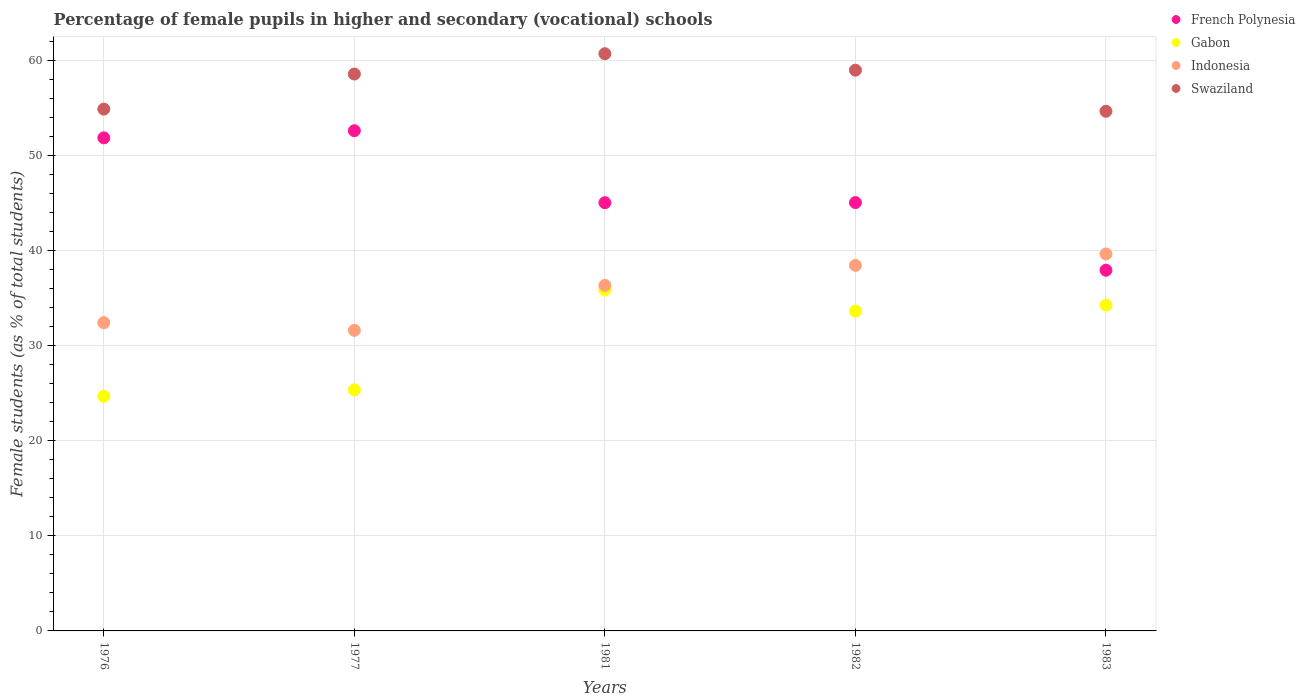What is the percentage of female pupils in higher and secondary schools in Gabon in 1982?
Give a very brief answer. 33.63. Across all years, what is the maximum percentage of female pupils in higher and secondary schools in Indonesia?
Provide a succinct answer. 39.64. Across all years, what is the minimum percentage of female pupils in higher and secondary schools in Gabon?
Provide a succinct answer. 24.67. In which year was the percentage of female pupils in higher and secondary schools in Gabon maximum?
Give a very brief answer. 1981. In which year was the percentage of female pupils in higher and secondary schools in Swaziland minimum?
Your answer should be compact. 1983. What is the total percentage of female pupils in higher and secondary schools in French Polynesia in the graph?
Give a very brief answer. 232.46. What is the difference between the percentage of female pupils in higher and secondary schools in Gabon in 1981 and that in 1983?
Your answer should be compact. 1.6. What is the difference between the percentage of female pupils in higher and secondary schools in French Polynesia in 1976 and the percentage of female pupils in higher and secondary schools in Swaziland in 1982?
Your response must be concise. -7.12. What is the average percentage of female pupils in higher and secondary schools in French Polynesia per year?
Your answer should be compact. 46.49. In the year 1981, what is the difference between the percentage of female pupils in higher and secondary schools in Gabon and percentage of female pupils in higher and secondary schools in Swaziland?
Your response must be concise. -24.84. In how many years, is the percentage of female pupils in higher and secondary schools in Gabon greater than 12 %?
Give a very brief answer. 5. What is the ratio of the percentage of female pupils in higher and secondary schools in French Polynesia in 1976 to that in 1977?
Provide a succinct answer. 0.99. What is the difference between the highest and the second highest percentage of female pupils in higher and secondary schools in French Polynesia?
Offer a terse response. 0.75. What is the difference between the highest and the lowest percentage of female pupils in higher and secondary schools in French Polynesia?
Provide a succinct answer. 14.67. Is the sum of the percentage of female pupils in higher and secondary schools in Swaziland in 1982 and 1983 greater than the maximum percentage of female pupils in higher and secondary schools in Gabon across all years?
Provide a succinct answer. Yes. Is it the case that in every year, the sum of the percentage of female pupils in higher and secondary schools in Swaziland and percentage of female pupils in higher and secondary schools in Indonesia  is greater than the percentage of female pupils in higher and secondary schools in French Polynesia?
Offer a very short reply. Yes. Is the percentage of female pupils in higher and secondary schools in French Polynesia strictly less than the percentage of female pupils in higher and secondary schools in Indonesia over the years?
Offer a terse response. No. How many years are there in the graph?
Your answer should be compact. 5. What is the difference between two consecutive major ticks on the Y-axis?
Give a very brief answer. 10. Are the values on the major ticks of Y-axis written in scientific E-notation?
Make the answer very short. No. Does the graph contain any zero values?
Ensure brevity in your answer.  No. How many legend labels are there?
Keep it short and to the point. 4. What is the title of the graph?
Your answer should be compact. Percentage of female pupils in higher and secondary (vocational) schools. Does "Kuwait" appear as one of the legend labels in the graph?
Provide a short and direct response. No. What is the label or title of the Y-axis?
Your answer should be compact. Female students (as % of total students). What is the Female students (as % of total students) in French Polynesia in 1976?
Provide a succinct answer. 51.85. What is the Female students (as % of total students) in Gabon in 1976?
Provide a succinct answer. 24.67. What is the Female students (as % of total students) in Indonesia in 1976?
Keep it short and to the point. 32.42. What is the Female students (as % of total students) of Swaziland in 1976?
Provide a short and direct response. 54.87. What is the Female students (as % of total students) of French Polynesia in 1977?
Ensure brevity in your answer.  52.6. What is the Female students (as % of total students) of Gabon in 1977?
Give a very brief answer. 25.35. What is the Female students (as % of total students) of Indonesia in 1977?
Your response must be concise. 31.61. What is the Female students (as % of total students) in Swaziland in 1977?
Ensure brevity in your answer.  58.56. What is the Female students (as % of total students) in French Polynesia in 1981?
Keep it short and to the point. 45.03. What is the Female students (as % of total students) of Gabon in 1981?
Make the answer very short. 35.86. What is the Female students (as % of total students) in Indonesia in 1981?
Your response must be concise. 36.34. What is the Female students (as % of total students) of Swaziland in 1981?
Your response must be concise. 60.7. What is the Female students (as % of total students) of French Polynesia in 1982?
Offer a very short reply. 45.04. What is the Female students (as % of total students) in Gabon in 1982?
Make the answer very short. 33.63. What is the Female students (as % of total students) of Indonesia in 1982?
Ensure brevity in your answer.  38.44. What is the Female students (as % of total students) in Swaziland in 1982?
Your response must be concise. 58.97. What is the Female students (as % of total students) in French Polynesia in 1983?
Provide a succinct answer. 37.93. What is the Female students (as % of total students) of Gabon in 1983?
Provide a short and direct response. 34.26. What is the Female students (as % of total students) in Indonesia in 1983?
Provide a succinct answer. 39.64. What is the Female students (as % of total students) of Swaziland in 1983?
Ensure brevity in your answer.  54.65. Across all years, what is the maximum Female students (as % of total students) in French Polynesia?
Your response must be concise. 52.6. Across all years, what is the maximum Female students (as % of total students) of Gabon?
Your answer should be compact. 35.86. Across all years, what is the maximum Female students (as % of total students) in Indonesia?
Provide a succinct answer. 39.64. Across all years, what is the maximum Female students (as % of total students) of Swaziland?
Your answer should be very brief. 60.7. Across all years, what is the minimum Female students (as % of total students) in French Polynesia?
Offer a very short reply. 37.93. Across all years, what is the minimum Female students (as % of total students) of Gabon?
Your answer should be very brief. 24.67. Across all years, what is the minimum Female students (as % of total students) of Indonesia?
Offer a very short reply. 31.61. Across all years, what is the minimum Female students (as % of total students) in Swaziland?
Provide a succinct answer. 54.65. What is the total Female students (as % of total students) of French Polynesia in the graph?
Make the answer very short. 232.46. What is the total Female students (as % of total students) in Gabon in the graph?
Offer a terse response. 153.77. What is the total Female students (as % of total students) in Indonesia in the graph?
Provide a short and direct response. 178.44. What is the total Female students (as % of total students) of Swaziland in the graph?
Your response must be concise. 287.75. What is the difference between the Female students (as % of total students) in French Polynesia in 1976 and that in 1977?
Give a very brief answer. -0.75. What is the difference between the Female students (as % of total students) of Gabon in 1976 and that in 1977?
Your answer should be very brief. -0.68. What is the difference between the Female students (as % of total students) in Indonesia in 1976 and that in 1977?
Your response must be concise. 0.81. What is the difference between the Female students (as % of total students) in Swaziland in 1976 and that in 1977?
Offer a terse response. -3.69. What is the difference between the Female students (as % of total students) of French Polynesia in 1976 and that in 1981?
Offer a terse response. 6.82. What is the difference between the Female students (as % of total students) in Gabon in 1976 and that in 1981?
Offer a very short reply. -11.19. What is the difference between the Female students (as % of total students) of Indonesia in 1976 and that in 1981?
Make the answer very short. -3.92. What is the difference between the Female students (as % of total students) in Swaziland in 1976 and that in 1981?
Your answer should be compact. -5.83. What is the difference between the Female students (as % of total students) of French Polynesia in 1976 and that in 1982?
Offer a terse response. 6.81. What is the difference between the Female students (as % of total students) of Gabon in 1976 and that in 1982?
Your answer should be compact. -8.96. What is the difference between the Female students (as % of total students) in Indonesia in 1976 and that in 1982?
Offer a very short reply. -6.02. What is the difference between the Female students (as % of total students) in Swaziland in 1976 and that in 1982?
Your answer should be very brief. -4.09. What is the difference between the Female students (as % of total students) of French Polynesia in 1976 and that in 1983?
Give a very brief answer. 13.92. What is the difference between the Female students (as % of total students) in Gabon in 1976 and that in 1983?
Provide a succinct answer. -9.59. What is the difference between the Female students (as % of total students) in Indonesia in 1976 and that in 1983?
Offer a very short reply. -7.22. What is the difference between the Female students (as % of total students) in Swaziland in 1976 and that in 1983?
Offer a terse response. 0.23. What is the difference between the Female students (as % of total students) of French Polynesia in 1977 and that in 1981?
Your response must be concise. 7.57. What is the difference between the Female students (as % of total students) of Gabon in 1977 and that in 1981?
Your answer should be very brief. -10.52. What is the difference between the Female students (as % of total students) in Indonesia in 1977 and that in 1981?
Keep it short and to the point. -4.73. What is the difference between the Female students (as % of total students) of Swaziland in 1977 and that in 1981?
Keep it short and to the point. -2.14. What is the difference between the Female students (as % of total students) in French Polynesia in 1977 and that in 1982?
Provide a succinct answer. 7.56. What is the difference between the Female students (as % of total students) in Gabon in 1977 and that in 1982?
Keep it short and to the point. -8.28. What is the difference between the Female students (as % of total students) in Indonesia in 1977 and that in 1982?
Offer a terse response. -6.83. What is the difference between the Female students (as % of total students) in Swaziland in 1977 and that in 1982?
Provide a short and direct response. -0.41. What is the difference between the Female students (as % of total students) in French Polynesia in 1977 and that in 1983?
Offer a terse response. 14.67. What is the difference between the Female students (as % of total students) in Gabon in 1977 and that in 1983?
Offer a terse response. -8.91. What is the difference between the Female students (as % of total students) of Indonesia in 1977 and that in 1983?
Offer a very short reply. -8.03. What is the difference between the Female students (as % of total students) in Swaziland in 1977 and that in 1983?
Ensure brevity in your answer.  3.91. What is the difference between the Female students (as % of total students) of French Polynesia in 1981 and that in 1982?
Ensure brevity in your answer.  -0.01. What is the difference between the Female students (as % of total students) of Gabon in 1981 and that in 1982?
Your answer should be very brief. 2.24. What is the difference between the Female students (as % of total students) in Indonesia in 1981 and that in 1982?
Offer a terse response. -2.1. What is the difference between the Female students (as % of total students) of Swaziland in 1981 and that in 1982?
Offer a terse response. 1.73. What is the difference between the Female students (as % of total students) of French Polynesia in 1981 and that in 1983?
Your answer should be compact. 7.1. What is the difference between the Female students (as % of total students) in Gabon in 1981 and that in 1983?
Offer a very short reply. 1.6. What is the difference between the Female students (as % of total students) of Indonesia in 1981 and that in 1983?
Ensure brevity in your answer.  -3.3. What is the difference between the Female students (as % of total students) in Swaziland in 1981 and that in 1983?
Make the answer very short. 6.05. What is the difference between the Female students (as % of total students) of French Polynesia in 1982 and that in 1983?
Offer a very short reply. 7.11. What is the difference between the Female students (as % of total students) in Gabon in 1982 and that in 1983?
Give a very brief answer. -0.63. What is the difference between the Female students (as % of total students) in Indonesia in 1982 and that in 1983?
Provide a short and direct response. -1.2. What is the difference between the Female students (as % of total students) of Swaziland in 1982 and that in 1983?
Ensure brevity in your answer.  4.32. What is the difference between the Female students (as % of total students) of French Polynesia in 1976 and the Female students (as % of total students) of Gabon in 1977?
Give a very brief answer. 26.5. What is the difference between the Female students (as % of total students) in French Polynesia in 1976 and the Female students (as % of total students) in Indonesia in 1977?
Keep it short and to the point. 20.24. What is the difference between the Female students (as % of total students) in French Polynesia in 1976 and the Female students (as % of total students) in Swaziland in 1977?
Provide a short and direct response. -6.71. What is the difference between the Female students (as % of total students) of Gabon in 1976 and the Female students (as % of total students) of Indonesia in 1977?
Your answer should be very brief. -6.94. What is the difference between the Female students (as % of total students) in Gabon in 1976 and the Female students (as % of total students) in Swaziland in 1977?
Offer a terse response. -33.89. What is the difference between the Female students (as % of total students) in Indonesia in 1976 and the Female students (as % of total students) in Swaziland in 1977?
Your answer should be very brief. -26.14. What is the difference between the Female students (as % of total students) of French Polynesia in 1976 and the Female students (as % of total students) of Gabon in 1981?
Make the answer very short. 15.99. What is the difference between the Female students (as % of total students) in French Polynesia in 1976 and the Female students (as % of total students) in Indonesia in 1981?
Give a very brief answer. 15.51. What is the difference between the Female students (as % of total students) in French Polynesia in 1976 and the Female students (as % of total students) in Swaziland in 1981?
Give a very brief answer. -8.85. What is the difference between the Female students (as % of total students) of Gabon in 1976 and the Female students (as % of total students) of Indonesia in 1981?
Provide a succinct answer. -11.67. What is the difference between the Female students (as % of total students) of Gabon in 1976 and the Female students (as % of total students) of Swaziland in 1981?
Your answer should be very brief. -36.03. What is the difference between the Female students (as % of total students) in Indonesia in 1976 and the Female students (as % of total students) in Swaziland in 1981?
Your answer should be compact. -28.28. What is the difference between the Female students (as % of total students) of French Polynesia in 1976 and the Female students (as % of total students) of Gabon in 1982?
Your answer should be very brief. 18.22. What is the difference between the Female students (as % of total students) in French Polynesia in 1976 and the Female students (as % of total students) in Indonesia in 1982?
Your answer should be compact. 13.41. What is the difference between the Female students (as % of total students) in French Polynesia in 1976 and the Female students (as % of total students) in Swaziland in 1982?
Offer a terse response. -7.12. What is the difference between the Female students (as % of total students) of Gabon in 1976 and the Female students (as % of total students) of Indonesia in 1982?
Your answer should be very brief. -13.77. What is the difference between the Female students (as % of total students) of Gabon in 1976 and the Female students (as % of total students) of Swaziland in 1982?
Your answer should be very brief. -34.29. What is the difference between the Female students (as % of total students) of Indonesia in 1976 and the Female students (as % of total students) of Swaziland in 1982?
Keep it short and to the point. -26.55. What is the difference between the Female students (as % of total students) of French Polynesia in 1976 and the Female students (as % of total students) of Gabon in 1983?
Give a very brief answer. 17.59. What is the difference between the Female students (as % of total students) of French Polynesia in 1976 and the Female students (as % of total students) of Indonesia in 1983?
Ensure brevity in your answer.  12.21. What is the difference between the Female students (as % of total students) of French Polynesia in 1976 and the Female students (as % of total students) of Swaziland in 1983?
Provide a succinct answer. -2.79. What is the difference between the Female students (as % of total students) of Gabon in 1976 and the Female students (as % of total students) of Indonesia in 1983?
Offer a very short reply. -14.97. What is the difference between the Female students (as % of total students) of Gabon in 1976 and the Female students (as % of total students) of Swaziland in 1983?
Keep it short and to the point. -29.97. What is the difference between the Female students (as % of total students) in Indonesia in 1976 and the Female students (as % of total students) in Swaziland in 1983?
Your answer should be very brief. -22.23. What is the difference between the Female students (as % of total students) of French Polynesia in 1977 and the Female students (as % of total students) of Gabon in 1981?
Provide a short and direct response. 16.74. What is the difference between the Female students (as % of total students) of French Polynesia in 1977 and the Female students (as % of total students) of Indonesia in 1981?
Your answer should be very brief. 16.26. What is the difference between the Female students (as % of total students) of French Polynesia in 1977 and the Female students (as % of total students) of Swaziland in 1981?
Your answer should be compact. -8.1. What is the difference between the Female students (as % of total students) in Gabon in 1977 and the Female students (as % of total students) in Indonesia in 1981?
Your response must be concise. -10.99. What is the difference between the Female students (as % of total students) in Gabon in 1977 and the Female students (as % of total students) in Swaziland in 1981?
Provide a succinct answer. -35.35. What is the difference between the Female students (as % of total students) in Indonesia in 1977 and the Female students (as % of total students) in Swaziland in 1981?
Ensure brevity in your answer.  -29.09. What is the difference between the Female students (as % of total students) in French Polynesia in 1977 and the Female students (as % of total students) in Gabon in 1982?
Offer a terse response. 18.97. What is the difference between the Female students (as % of total students) of French Polynesia in 1977 and the Female students (as % of total students) of Indonesia in 1982?
Your answer should be very brief. 14.16. What is the difference between the Female students (as % of total students) of French Polynesia in 1977 and the Female students (as % of total students) of Swaziland in 1982?
Keep it short and to the point. -6.37. What is the difference between the Female students (as % of total students) in Gabon in 1977 and the Female students (as % of total students) in Indonesia in 1982?
Provide a short and direct response. -13.09. What is the difference between the Female students (as % of total students) in Gabon in 1977 and the Female students (as % of total students) in Swaziland in 1982?
Offer a terse response. -33.62. What is the difference between the Female students (as % of total students) in Indonesia in 1977 and the Female students (as % of total students) in Swaziland in 1982?
Ensure brevity in your answer.  -27.36. What is the difference between the Female students (as % of total students) of French Polynesia in 1977 and the Female students (as % of total students) of Gabon in 1983?
Give a very brief answer. 18.34. What is the difference between the Female students (as % of total students) of French Polynesia in 1977 and the Female students (as % of total students) of Indonesia in 1983?
Your answer should be compact. 12.96. What is the difference between the Female students (as % of total students) in French Polynesia in 1977 and the Female students (as % of total students) in Swaziland in 1983?
Offer a terse response. -2.04. What is the difference between the Female students (as % of total students) in Gabon in 1977 and the Female students (as % of total students) in Indonesia in 1983?
Your answer should be very brief. -14.29. What is the difference between the Female students (as % of total students) of Gabon in 1977 and the Female students (as % of total students) of Swaziland in 1983?
Ensure brevity in your answer.  -29.3. What is the difference between the Female students (as % of total students) of Indonesia in 1977 and the Female students (as % of total students) of Swaziland in 1983?
Provide a short and direct response. -23.04. What is the difference between the Female students (as % of total students) in French Polynesia in 1981 and the Female students (as % of total students) in Gabon in 1982?
Your answer should be very brief. 11.41. What is the difference between the Female students (as % of total students) of French Polynesia in 1981 and the Female students (as % of total students) of Indonesia in 1982?
Provide a short and direct response. 6.59. What is the difference between the Female students (as % of total students) in French Polynesia in 1981 and the Female students (as % of total students) in Swaziland in 1982?
Keep it short and to the point. -13.93. What is the difference between the Female students (as % of total students) in Gabon in 1981 and the Female students (as % of total students) in Indonesia in 1982?
Give a very brief answer. -2.58. What is the difference between the Female students (as % of total students) of Gabon in 1981 and the Female students (as % of total students) of Swaziland in 1982?
Your answer should be compact. -23.1. What is the difference between the Female students (as % of total students) of Indonesia in 1981 and the Female students (as % of total students) of Swaziland in 1982?
Keep it short and to the point. -22.63. What is the difference between the Female students (as % of total students) of French Polynesia in 1981 and the Female students (as % of total students) of Gabon in 1983?
Your answer should be compact. 10.77. What is the difference between the Female students (as % of total students) in French Polynesia in 1981 and the Female students (as % of total students) in Indonesia in 1983?
Provide a succinct answer. 5.39. What is the difference between the Female students (as % of total students) in French Polynesia in 1981 and the Female students (as % of total students) in Swaziland in 1983?
Offer a very short reply. -9.61. What is the difference between the Female students (as % of total students) in Gabon in 1981 and the Female students (as % of total students) in Indonesia in 1983?
Make the answer very short. -3.78. What is the difference between the Female students (as % of total students) of Gabon in 1981 and the Female students (as % of total students) of Swaziland in 1983?
Make the answer very short. -18.78. What is the difference between the Female students (as % of total students) in Indonesia in 1981 and the Female students (as % of total students) in Swaziland in 1983?
Your answer should be very brief. -18.31. What is the difference between the Female students (as % of total students) in French Polynesia in 1982 and the Female students (as % of total students) in Gabon in 1983?
Provide a short and direct response. 10.79. What is the difference between the Female students (as % of total students) in French Polynesia in 1982 and the Female students (as % of total students) in Indonesia in 1983?
Give a very brief answer. 5.41. What is the difference between the Female students (as % of total students) of French Polynesia in 1982 and the Female students (as % of total students) of Swaziland in 1983?
Your answer should be very brief. -9.6. What is the difference between the Female students (as % of total students) in Gabon in 1982 and the Female students (as % of total students) in Indonesia in 1983?
Provide a short and direct response. -6.01. What is the difference between the Female students (as % of total students) of Gabon in 1982 and the Female students (as % of total students) of Swaziland in 1983?
Provide a succinct answer. -21.02. What is the difference between the Female students (as % of total students) of Indonesia in 1982 and the Female students (as % of total students) of Swaziland in 1983?
Your answer should be very brief. -16.21. What is the average Female students (as % of total students) in French Polynesia per year?
Offer a terse response. 46.49. What is the average Female students (as % of total students) of Gabon per year?
Provide a short and direct response. 30.75. What is the average Female students (as % of total students) in Indonesia per year?
Offer a very short reply. 35.69. What is the average Female students (as % of total students) in Swaziland per year?
Keep it short and to the point. 57.55. In the year 1976, what is the difference between the Female students (as % of total students) of French Polynesia and Female students (as % of total students) of Gabon?
Your answer should be very brief. 27.18. In the year 1976, what is the difference between the Female students (as % of total students) of French Polynesia and Female students (as % of total students) of Indonesia?
Offer a very short reply. 19.43. In the year 1976, what is the difference between the Female students (as % of total students) in French Polynesia and Female students (as % of total students) in Swaziland?
Keep it short and to the point. -3.02. In the year 1976, what is the difference between the Female students (as % of total students) of Gabon and Female students (as % of total students) of Indonesia?
Offer a terse response. -7.75. In the year 1976, what is the difference between the Female students (as % of total students) of Gabon and Female students (as % of total students) of Swaziland?
Provide a short and direct response. -30.2. In the year 1976, what is the difference between the Female students (as % of total students) in Indonesia and Female students (as % of total students) in Swaziland?
Ensure brevity in your answer.  -22.46. In the year 1977, what is the difference between the Female students (as % of total students) in French Polynesia and Female students (as % of total students) in Gabon?
Provide a succinct answer. 27.25. In the year 1977, what is the difference between the Female students (as % of total students) of French Polynesia and Female students (as % of total students) of Indonesia?
Make the answer very short. 20.99. In the year 1977, what is the difference between the Female students (as % of total students) of French Polynesia and Female students (as % of total students) of Swaziland?
Your response must be concise. -5.96. In the year 1977, what is the difference between the Female students (as % of total students) in Gabon and Female students (as % of total students) in Indonesia?
Offer a very short reply. -6.26. In the year 1977, what is the difference between the Female students (as % of total students) in Gabon and Female students (as % of total students) in Swaziland?
Offer a very short reply. -33.21. In the year 1977, what is the difference between the Female students (as % of total students) in Indonesia and Female students (as % of total students) in Swaziland?
Offer a very short reply. -26.95. In the year 1981, what is the difference between the Female students (as % of total students) in French Polynesia and Female students (as % of total students) in Gabon?
Your answer should be very brief. 9.17. In the year 1981, what is the difference between the Female students (as % of total students) in French Polynesia and Female students (as % of total students) in Indonesia?
Ensure brevity in your answer.  8.69. In the year 1981, what is the difference between the Female students (as % of total students) of French Polynesia and Female students (as % of total students) of Swaziland?
Your answer should be very brief. -15.67. In the year 1981, what is the difference between the Female students (as % of total students) in Gabon and Female students (as % of total students) in Indonesia?
Offer a very short reply. -0.48. In the year 1981, what is the difference between the Female students (as % of total students) in Gabon and Female students (as % of total students) in Swaziland?
Provide a short and direct response. -24.84. In the year 1981, what is the difference between the Female students (as % of total students) of Indonesia and Female students (as % of total students) of Swaziland?
Offer a very short reply. -24.36. In the year 1982, what is the difference between the Female students (as % of total students) in French Polynesia and Female students (as % of total students) in Gabon?
Provide a short and direct response. 11.42. In the year 1982, what is the difference between the Female students (as % of total students) in French Polynesia and Female students (as % of total students) in Indonesia?
Your answer should be compact. 6.6. In the year 1982, what is the difference between the Female students (as % of total students) in French Polynesia and Female students (as % of total students) in Swaziland?
Provide a short and direct response. -13.92. In the year 1982, what is the difference between the Female students (as % of total students) of Gabon and Female students (as % of total students) of Indonesia?
Your response must be concise. -4.81. In the year 1982, what is the difference between the Female students (as % of total students) of Gabon and Female students (as % of total students) of Swaziland?
Your response must be concise. -25.34. In the year 1982, what is the difference between the Female students (as % of total students) of Indonesia and Female students (as % of total students) of Swaziland?
Ensure brevity in your answer.  -20.53. In the year 1983, what is the difference between the Female students (as % of total students) in French Polynesia and Female students (as % of total students) in Gabon?
Ensure brevity in your answer.  3.67. In the year 1983, what is the difference between the Female students (as % of total students) in French Polynesia and Female students (as % of total students) in Indonesia?
Your response must be concise. -1.71. In the year 1983, what is the difference between the Female students (as % of total students) in French Polynesia and Female students (as % of total students) in Swaziland?
Make the answer very short. -16.71. In the year 1983, what is the difference between the Female students (as % of total students) of Gabon and Female students (as % of total students) of Indonesia?
Give a very brief answer. -5.38. In the year 1983, what is the difference between the Female students (as % of total students) of Gabon and Female students (as % of total students) of Swaziland?
Provide a succinct answer. -20.39. In the year 1983, what is the difference between the Female students (as % of total students) of Indonesia and Female students (as % of total students) of Swaziland?
Ensure brevity in your answer.  -15.01. What is the ratio of the Female students (as % of total students) in French Polynesia in 1976 to that in 1977?
Provide a short and direct response. 0.99. What is the ratio of the Female students (as % of total students) of Gabon in 1976 to that in 1977?
Provide a succinct answer. 0.97. What is the ratio of the Female students (as % of total students) in Indonesia in 1976 to that in 1977?
Your answer should be compact. 1.03. What is the ratio of the Female students (as % of total students) of Swaziland in 1976 to that in 1977?
Your response must be concise. 0.94. What is the ratio of the Female students (as % of total students) in French Polynesia in 1976 to that in 1981?
Your answer should be very brief. 1.15. What is the ratio of the Female students (as % of total students) of Gabon in 1976 to that in 1981?
Your response must be concise. 0.69. What is the ratio of the Female students (as % of total students) of Indonesia in 1976 to that in 1981?
Your answer should be very brief. 0.89. What is the ratio of the Female students (as % of total students) in Swaziland in 1976 to that in 1981?
Provide a succinct answer. 0.9. What is the ratio of the Female students (as % of total students) of French Polynesia in 1976 to that in 1982?
Your response must be concise. 1.15. What is the ratio of the Female students (as % of total students) in Gabon in 1976 to that in 1982?
Make the answer very short. 0.73. What is the ratio of the Female students (as % of total students) in Indonesia in 1976 to that in 1982?
Your response must be concise. 0.84. What is the ratio of the Female students (as % of total students) of Swaziland in 1976 to that in 1982?
Your answer should be very brief. 0.93. What is the ratio of the Female students (as % of total students) in French Polynesia in 1976 to that in 1983?
Your answer should be compact. 1.37. What is the ratio of the Female students (as % of total students) in Gabon in 1976 to that in 1983?
Give a very brief answer. 0.72. What is the ratio of the Female students (as % of total students) of Indonesia in 1976 to that in 1983?
Offer a very short reply. 0.82. What is the ratio of the Female students (as % of total students) in French Polynesia in 1977 to that in 1981?
Provide a succinct answer. 1.17. What is the ratio of the Female students (as % of total students) in Gabon in 1977 to that in 1981?
Make the answer very short. 0.71. What is the ratio of the Female students (as % of total students) in Indonesia in 1977 to that in 1981?
Make the answer very short. 0.87. What is the ratio of the Female students (as % of total students) in Swaziland in 1977 to that in 1981?
Provide a short and direct response. 0.96. What is the ratio of the Female students (as % of total students) of French Polynesia in 1977 to that in 1982?
Make the answer very short. 1.17. What is the ratio of the Female students (as % of total students) in Gabon in 1977 to that in 1982?
Make the answer very short. 0.75. What is the ratio of the Female students (as % of total students) of Indonesia in 1977 to that in 1982?
Your answer should be compact. 0.82. What is the ratio of the Female students (as % of total students) in French Polynesia in 1977 to that in 1983?
Offer a very short reply. 1.39. What is the ratio of the Female students (as % of total students) in Gabon in 1977 to that in 1983?
Offer a very short reply. 0.74. What is the ratio of the Female students (as % of total students) of Indonesia in 1977 to that in 1983?
Ensure brevity in your answer.  0.8. What is the ratio of the Female students (as % of total students) of Swaziland in 1977 to that in 1983?
Keep it short and to the point. 1.07. What is the ratio of the Female students (as % of total students) in French Polynesia in 1981 to that in 1982?
Provide a short and direct response. 1. What is the ratio of the Female students (as % of total students) in Gabon in 1981 to that in 1982?
Provide a succinct answer. 1.07. What is the ratio of the Female students (as % of total students) in Indonesia in 1981 to that in 1982?
Keep it short and to the point. 0.95. What is the ratio of the Female students (as % of total students) in Swaziland in 1981 to that in 1982?
Give a very brief answer. 1.03. What is the ratio of the Female students (as % of total students) of French Polynesia in 1981 to that in 1983?
Keep it short and to the point. 1.19. What is the ratio of the Female students (as % of total students) of Gabon in 1981 to that in 1983?
Make the answer very short. 1.05. What is the ratio of the Female students (as % of total students) of Indonesia in 1981 to that in 1983?
Your response must be concise. 0.92. What is the ratio of the Female students (as % of total students) of Swaziland in 1981 to that in 1983?
Make the answer very short. 1.11. What is the ratio of the Female students (as % of total students) of French Polynesia in 1982 to that in 1983?
Provide a succinct answer. 1.19. What is the ratio of the Female students (as % of total students) of Gabon in 1982 to that in 1983?
Offer a very short reply. 0.98. What is the ratio of the Female students (as % of total students) in Indonesia in 1982 to that in 1983?
Give a very brief answer. 0.97. What is the ratio of the Female students (as % of total students) of Swaziland in 1982 to that in 1983?
Offer a very short reply. 1.08. What is the difference between the highest and the second highest Female students (as % of total students) in French Polynesia?
Offer a terse response. 0.75. What is the difference between the highest and the second highest Female students (as % of total students) in Gabon?
Your answer should be compact. 1.6. What is the difference between the highest and the second highest Female students (as % of total students) in Indonesia?
Provide a succinct answer. 1.2. What is the difference between the highest and the second highest Female students (as % of total students) in Swaziland?
Your answer should be compact. 1.73. What is the difference between the highest and the lowest Female students (as % of total students) in French Polynesia?
Offer a terse response. 14.67. What is the difference between the highest and the lowest Female students (as % of total students) of Gabon?
Provide a succinct answer. 11.19. What is the difference between the highest and the lowest Female students (as % of total students) in Indonesia?
Ensure brevity in your answer.  8.03. What is the difference between the highest and the lowest Female students (as % of total students) in Swaziland?
Provide a succinct answer. 6.05. 